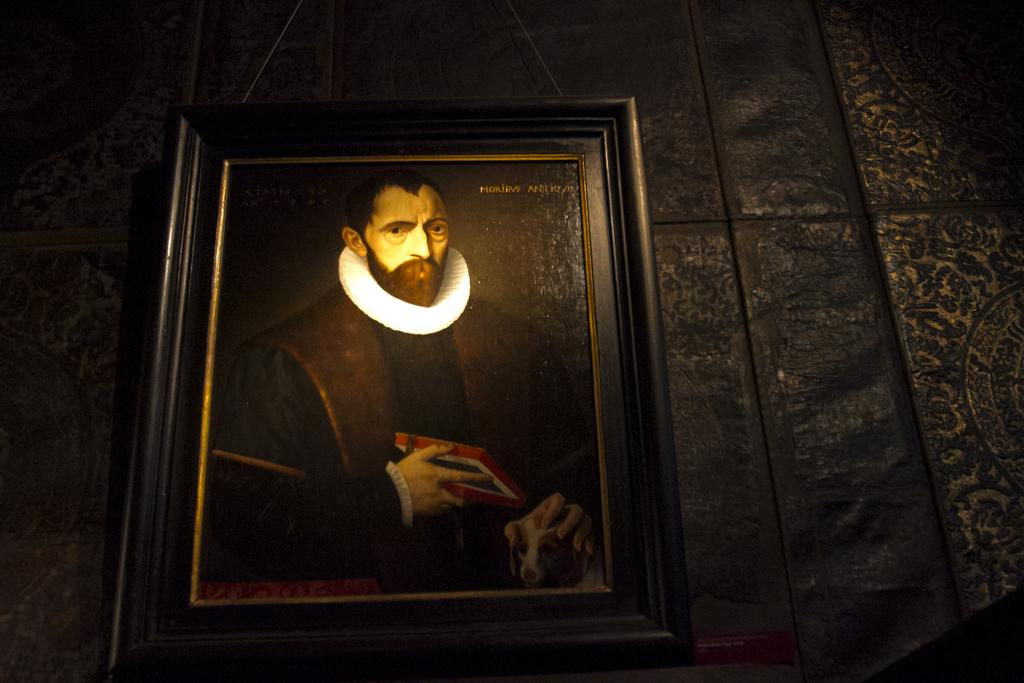What is hanging on the wall in the image? There is a photo frame on the wall in the image. What type of bird can be seen flying near the photo frame in the image? There is no bird present in the image; it only features a photo frame on the wall. Is the light bulb in the photo frame visible in the image? There is no mention of a light bulb or any other object inside the photo frame in the provided facts, so it cannot be determined from the image. 